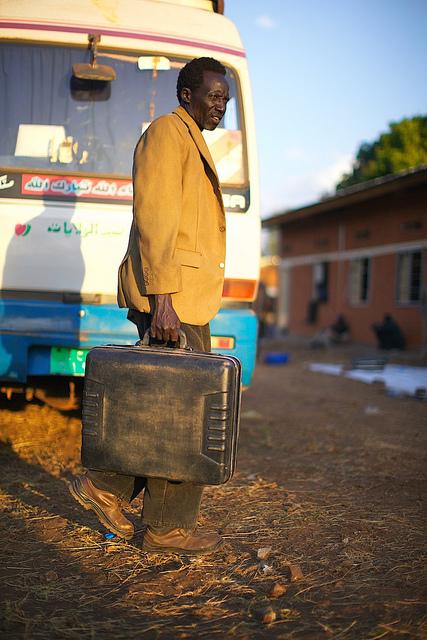Is the man on a trip?
Be succinct. Yes. Is this in America?
Answer briefly. No. What color is the bumper of the bus?
Be succinct. Blue. 